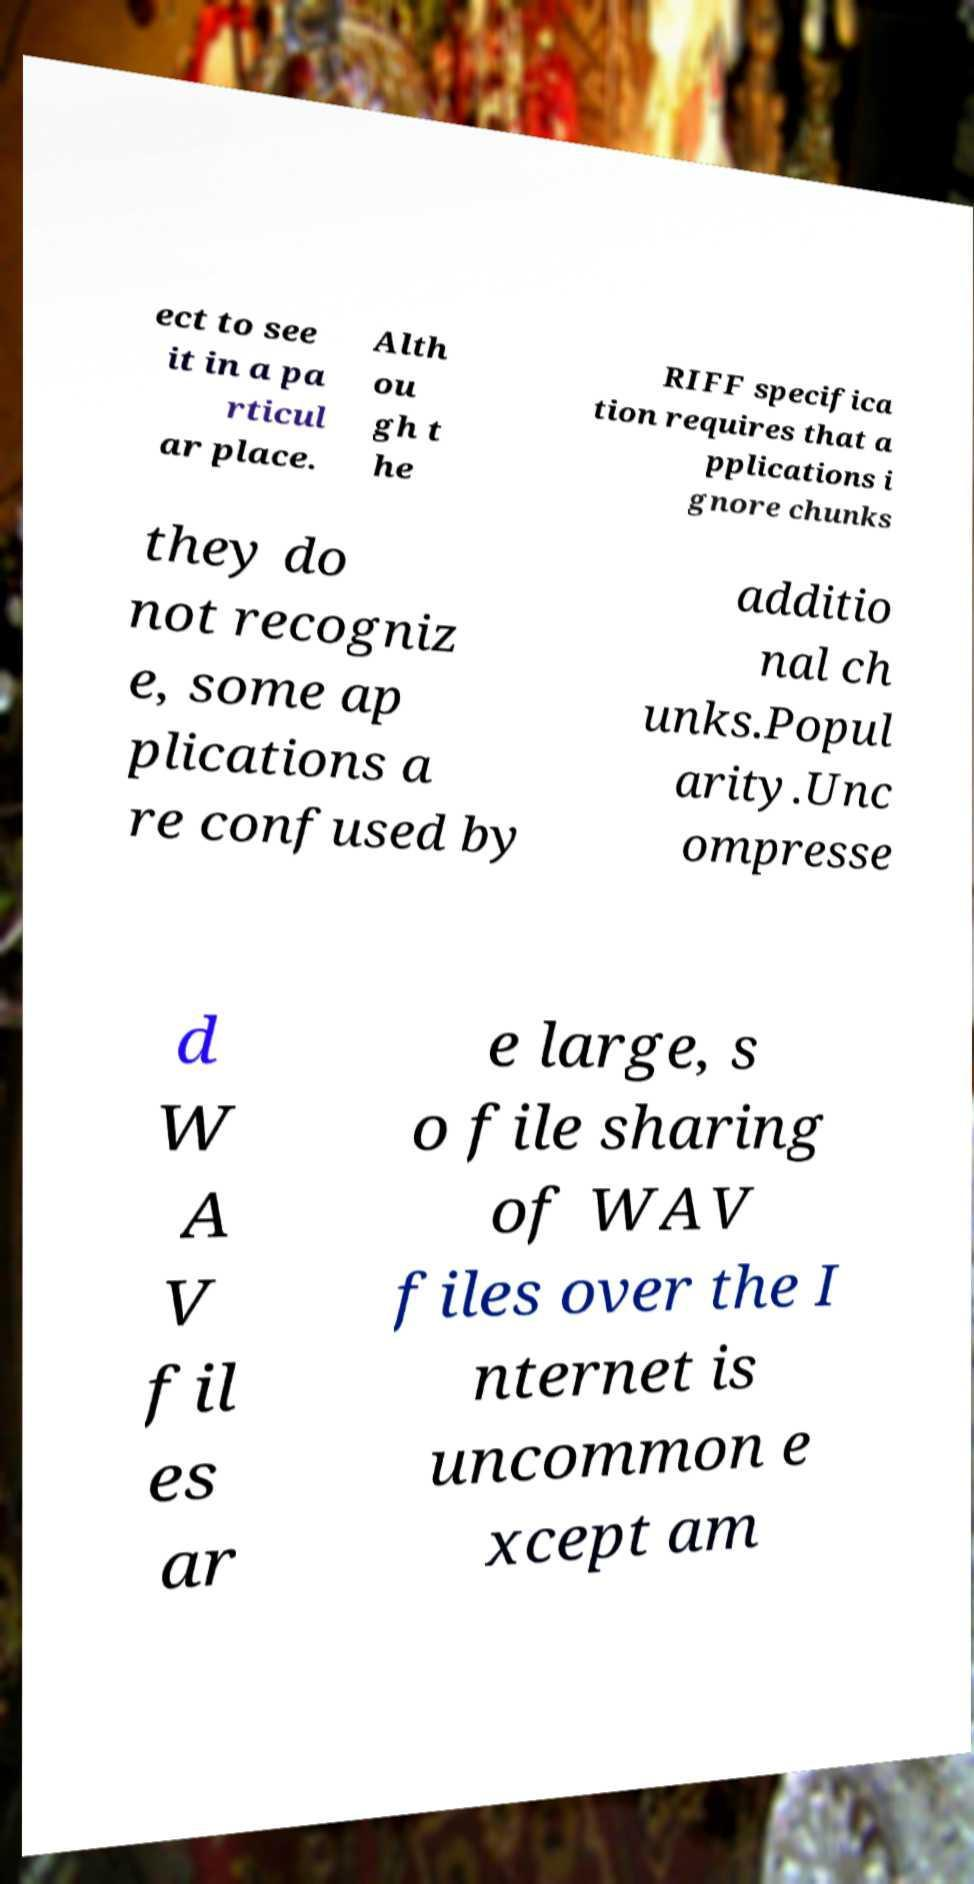For documentation purposes, I need the text within this image transcribed. Could you provide that? ect to see it in a pa rticul ar place. Alth ou gh t he RIFF specifica tion requires that a pplications i gnore chunks they do not recogniz e, some ap plications a re confused by additio nal ch unks.Popul arity.Unc ompresse d W A V fil es ar e large, s o file sharing of WAV files over the I nternet is uncommon e xcept am 